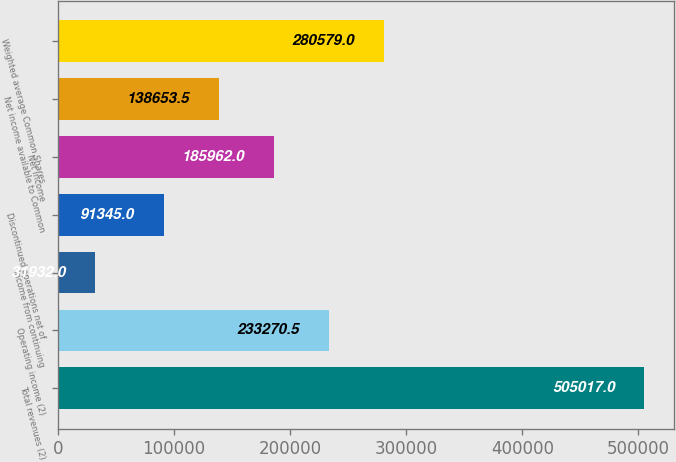<chart> <loc_0><loc_0><loc_500><loc_500><bar_chart><fcel>Total revenues (2)<fcel>Operating income (2)<fcel>Income from continuing<fcel>Discontinued operations net of<fcel>Net income<fcel>Net income available to Common<fcel>Weighted average Common Shares<nl><fcel>505017<fcel>233270<fcel>31932<fcel>91345<fcel>185962<fcel>138654<fcel>280579<nl></chart> 